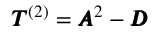Convert formula to latex. <formula><loc_0><loc_0><loc_500><loc_500>\pm b { T } ^ { ( 2 ) } = \pm b { A } ^ { 2 } - \pm b { D }</formula> 